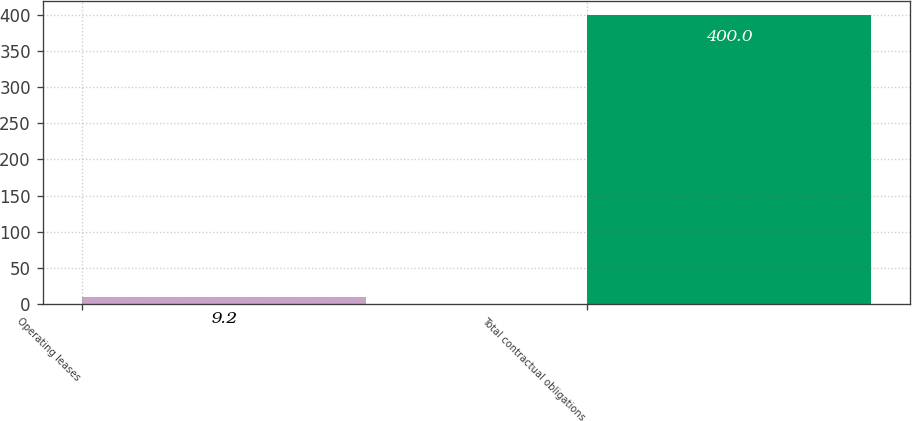<chart> <loc_0><loc_0><loc_500><loc_500><bar_chart><fcel>Operating leases<fcel>Total contractual obligations<nl><fcel>9.2<fcel>400<nl></chart> 